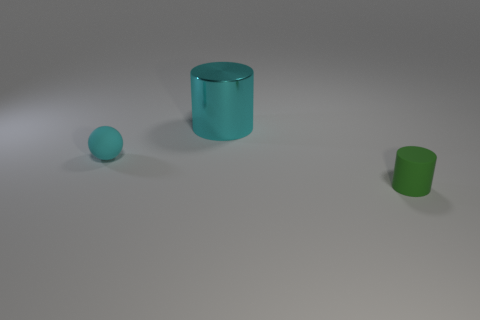There is another object that is the same material as the green thing; what color is it?
Provide a short and direct response. Cyan. What shape is the big thing?
Offer a terse response. Cylinder. How many tiny matte spheres are the same color as the metal object?
Offer a very short reply. 1. What is the shape of the green thing that is the same size as the rubber ball?
Your answer should be compact. Cylinder. Are there any gray shiny spheres of the same size as the matte sphere?
Your response must be concise. No. There is a cyan thing that is the same size as the matte cylinder; what material is it?
Provide a succinct answer. Rubber. There is a thing that is behind the small thing on the left side of the large thing; what is its size?
Provide a short and direct response. Large. There is a object behind the cyan matte object; is its size the same as the tiny cylinder?
Offer a terse response. No. Is the number of cyan rubber objects that are in front of the cyan metallic object greater than the number of large cyan objects in front of the tiny green thing?
Offer a terse response. Yes. What is the shape of the object that is to the left of the tiny green object and right of the matte sphere?
Your answer should be compact. Cylinder. 